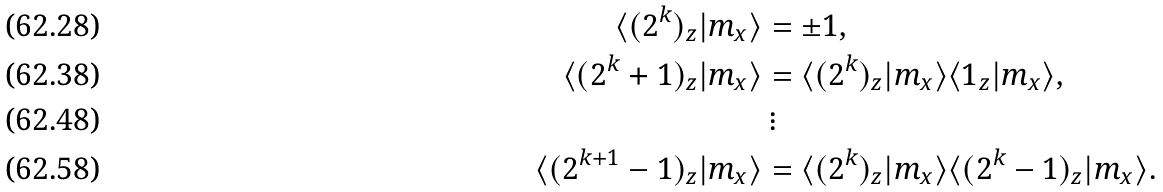<formula> <loc_0><loc_0><loc_500><loc_500>\langle ( 2 ^ { k } ) _ { z } | m _ { x } \rangle & = \pm 1 , \\ \langle ( 2 ^ { k } + 1 ) _ { z } | m _ { x } \rangle & = \langle ( 2 ^ { k } ) _ { z } | m _ { x } \rangle \langle 1 _ { z } | m _ { x } \rangle , \\ & \, \vdots \\ \langle ( 2 ^ { k + 1 } - 1 ) _ { z } | m _ { x } \rangle & = \langle ( 2 ^ { k } ) _ { z } | m _ { x } \rangle \langle ( 2 ^ { k } - 1 ) _ { z } | m _ { x } \rangle .</formula> 